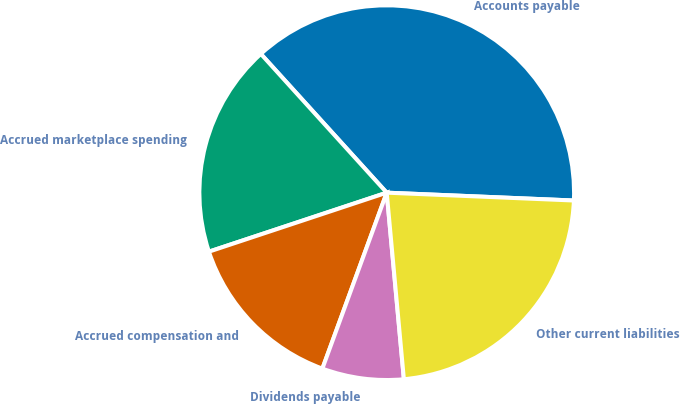Convert chart to OTSL. <chart><loc_0><loc_0><loc_500><loc_500><pie_chart><fcel>Accounts payable<fcel>Accrued marketplace spending<fcel>Accrued compensation and<fcel>Dividends payable<fcel>Other current liabilities<nl><fcel>37.39%<fcel>18.37%<fcel>14.32%<fcel>7.04%<fcel>22.87%<nl></chart> 